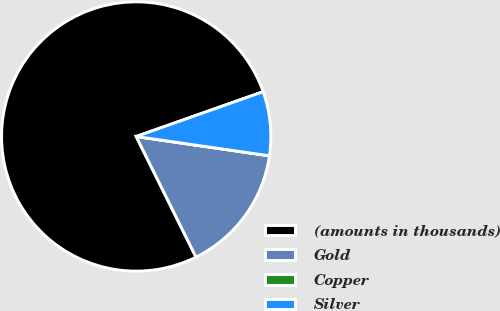<chart> <loc_0><loc_0><loc_500><loc_500><pie_chart><fcel>(amounts in thousands)<fcel>Gold<fcel>Copper<fcel>Silver<nl><fcel>76.92%<fcel>15.38%<fcel>0.0%<fcel>7.69%<nl></chart> 